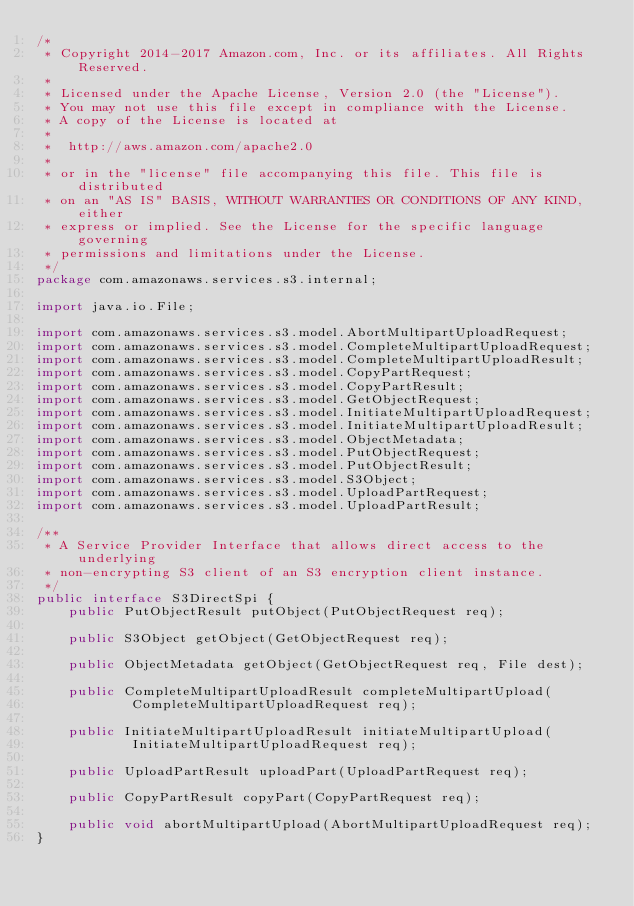Convert code to text. <code><loc_0><loc_0><loc_500><loc_500><_Java_>/*
 * Copyright 2014-2017 Amazon.com, Inc. or its affiliates. All Rights Reserved.
 *
 * Licensed under the Apache License, Version 2.0 (the "License").
 * You may not use this file except in compliance with the License.
 * A copy of the License is located at
 *
 *  http://aws.amazon.com/apache2.0
 *
 * or in the "license" file accompanying this file. This file is distributed
 * on an "AS IS" BASIS, WITHOUT WARRANTIES OR CONDITIONS OF ANY KIND, either
 * express or implied. See the License for the specific language governing
 * permissions and limitations under the License.
 */
package com.amazonaws.services.s3.internal;

import java.io.File;

import com.amazonaws.services.s3.model.AbortMultipartUploadRequest;
import com.amazonaws.services.s3.model.CompleteMultipartUploadRequest;
import com.amazonaws.services.s3.model.CompleteMultipartUploadResult;
import com.amazonaws.services.s3.model.CopyPartRequest;
import com.amazonaws.services.s3.model.CopyPartResult;
import com.amazonaws.services.s3.model.GetObjectRequest;
import com.amazonaws.services.s3.model.InitiateMultipartUploadRequest;
import com.amazonaws.services.s3.model.InitiateMultipartUploadResult;
import com.amazonaws.services.s3.model.ObjectMetadata;
import com.amazonaws.services.s3.model.PutObjectRequest;
import com.amazonaws.services.s3.model.PutObjectResult;
import com.amazonaws.services.s3.model.S3Object;
import com.amazonaws.services.s3.model.UploadPartRequest;
import com.amazonaws.services.s3.model.UploadPartResult;

/**
 * A Service Provider Interface that allows direct access to the underlying
 * non-encrypting S3 client of an S3 encryption client instance.
 */
public interface S3DirectSpi {
    public PutObjectResult putObject(PutObjectRequest req);

    public S3Object getObject(GetObjectRequest req);

    public ObjectMetadata getObject(GetObjectRequest req, File dest);

    public CompleteMultipartUploadResult completeMultipartUpload(
            CompleteMultipartUploadRequest req);

    public InitiateMultipartUploadResult initiateMultipartUpload(
            InitiateMultipartUploadRequest req);

    public UploadPartResult uploadPart(UploadPartRequest req);

    public CopyPartResult copyPart(CopyPartRequest req);

    public void abortMultipartUpload(AbortMultipartUploadRequest req);
}
</code> 